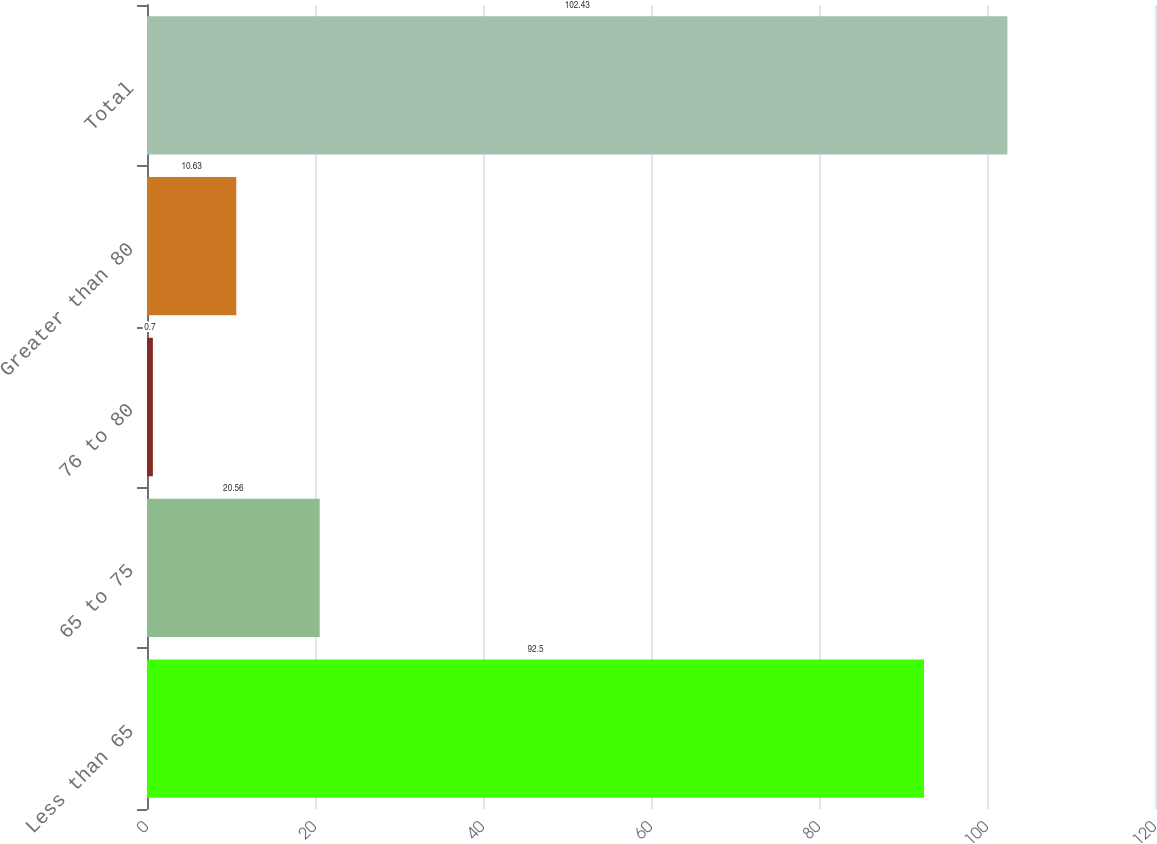<chart> <loc_0><loc_0><loc_500><loc_500><bar_chart><fcel>Less than 65<fcel>65 to 75<fcel>76 to 80<fcel>Greater than 80<fcel>Total<nl><fcel>92.5<fcel>20.56<fcel>0.7<fcel>10.63<fcel>102.43<nl></chart> 